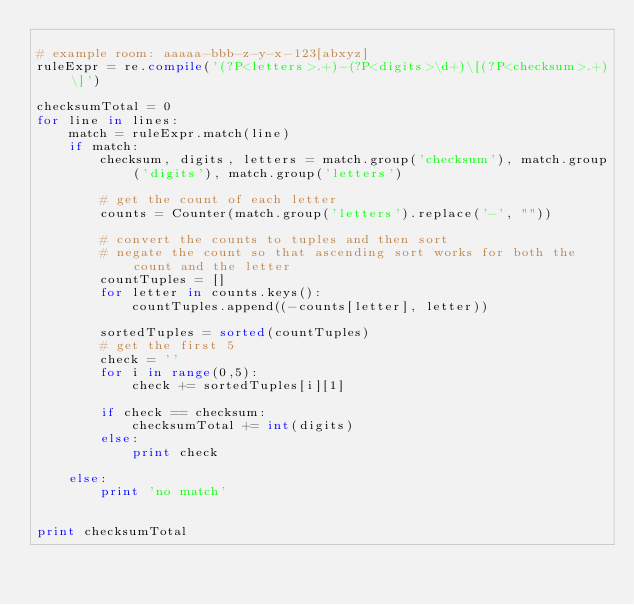Convert code to text. <code><loc_0><loc_0><loc_500><loc_500><_Python_>
# example room: aaaaa-bbb-z-y-x-123[abxyz]
ruleExpr = re.compile('(?P<letters>.+)-(?P<digits>\d+)\[(?P<checksum>.+)\]')

checksumTotal = 0
for line in lines:
    match = ruleExpr.match(line)
    if match:
        checksum, digits, letters = match.group('checksum'), match.group('digits'), match.group('letters')

        # get the count of each letter
        counts = Counter(match.group('letters').replace('-', ""))

        # convert the counts to tuples and then sort
        # negate the count so that ascending sort works for both the count and the letter
        countTuples = []
        for letter in counts.keys():
            countTuples.append((-counts[letter], letter))

        sortedTuples = sorted(countTuples)
        # get the first 5
        check = ''
        for i in range(0,5):
            check += sortedTuples[i][1]

        if check == checksum:
            checksumTotal += int(digits)
        else:
            print check

    else:
        print 'no match'


print checksumTotal</code> 